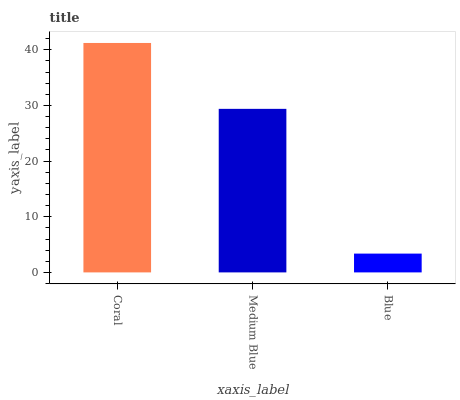Is Blue the minimum?
Answer yes or no. Yes. Is Coral the maximum?
Answer yes or no. Yes. Is Medium Blue the minimum?
Answer yes or no. No. Is Medium Blue the maximum?
Answer yes or no. No. Is Coral greater than Medium Blue?
Answer yes or no. Yes. Is Medium Blue less than Coral?
Answer yes or no. Yes. Is Medium Blue greater than Coral?
Answer yes or no. No. Is Coral less than Medium Blue?
Answer yes or no. No. Is Medium Blue the high median?
Answer yes or no. Yes. Is Medium Blue the low median?
Answer yes or no. Yes. Is Blue the high median?
Answer yes or no. No. Is Blue the low median?
Answer yes or no. No. 